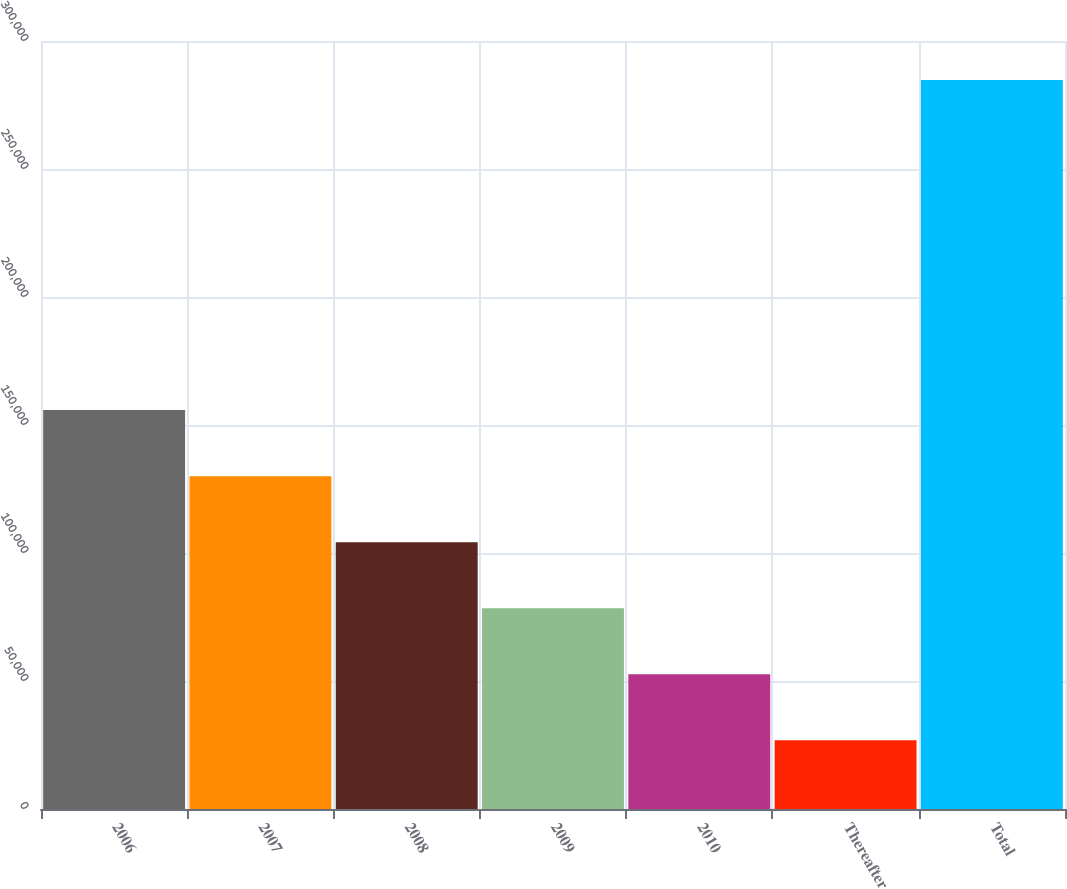Convert chart. <chart><loc_0><loc_0><loc_500><loc_500><bar_chart><fcel>2006<fcel>2007<fcel>2008<fcel>2009<fcel>2010<fcel>Thereafter<fcel>Total<nl><fcel>155822<fcel>130027<fcel>104232<fcel>78437.6<fcel>52642.8<fcel>26848<fcel>284796<nl></chart> 